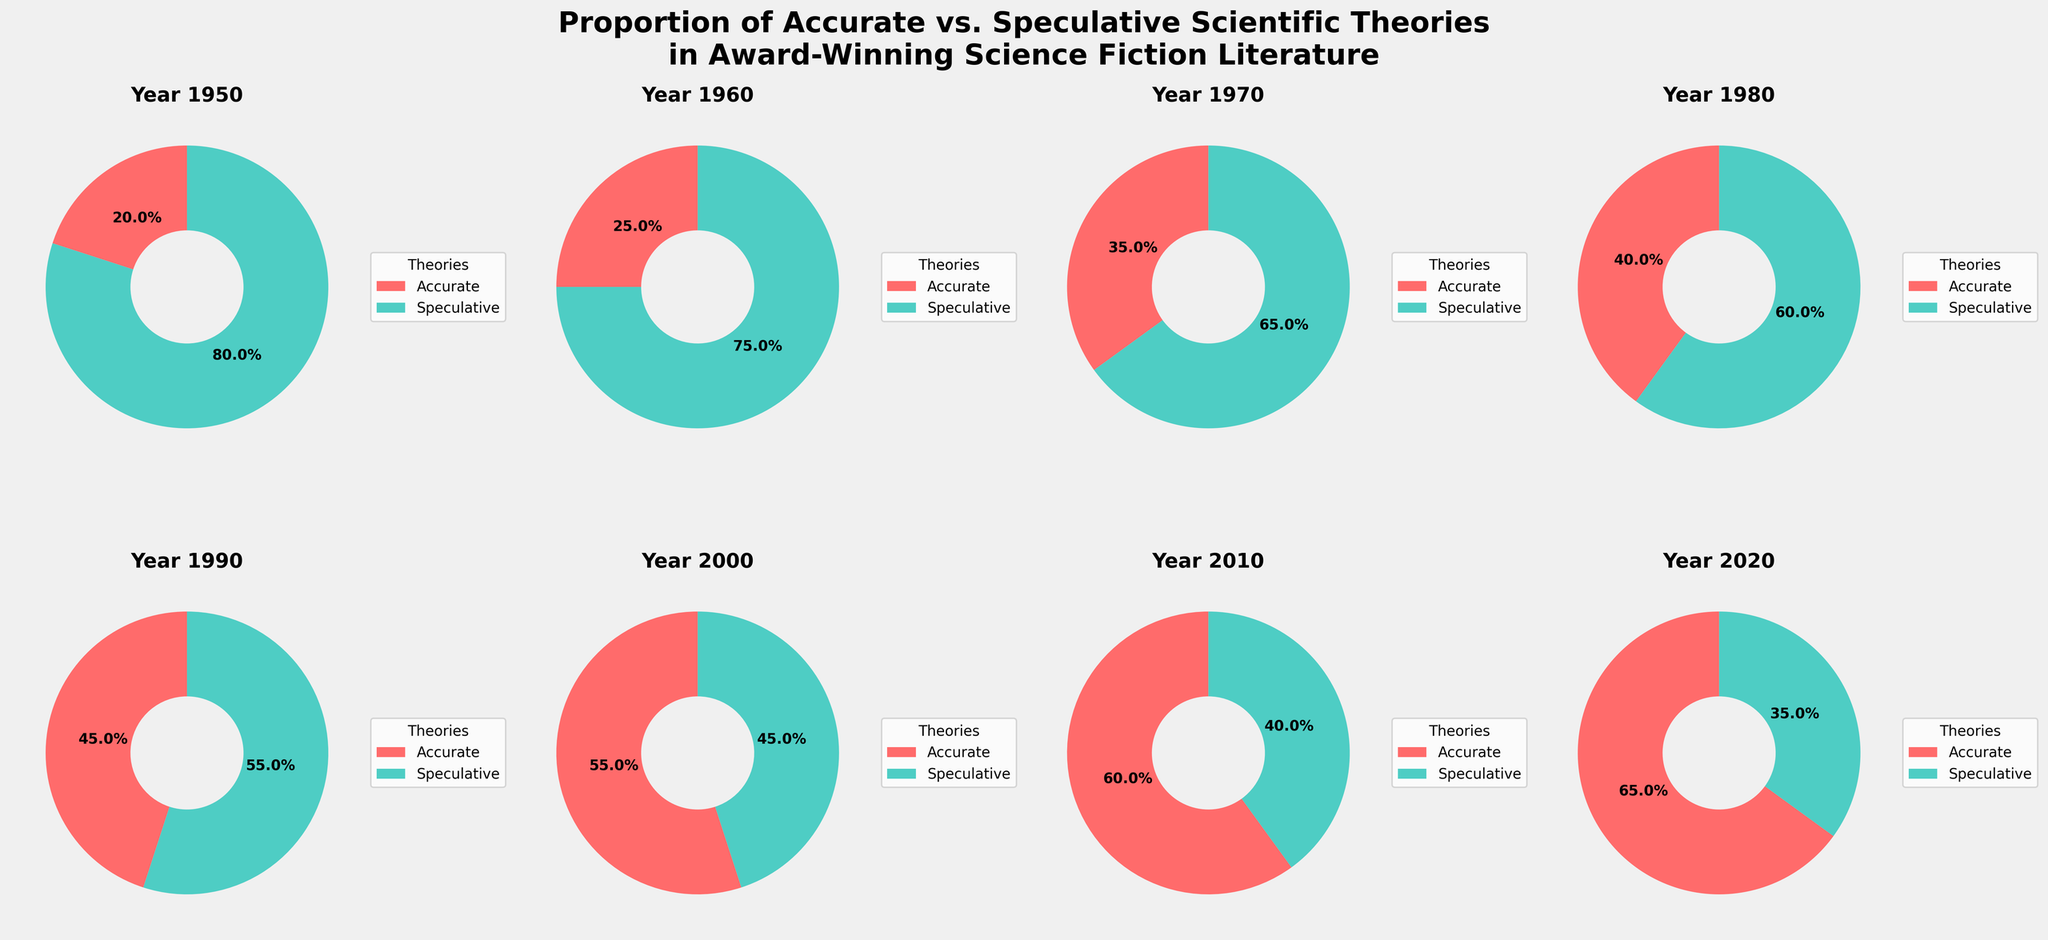Which year had the highest proportion of accurate scientific theories? By looking at the pie chart slices and their percentages, the year with the highest proportion of accurate scientific theories can be found out. From the figure, it's clear that 2020 has the largest slice for accurate theories.
Answer: 2020 What's the difference in the percentage of accurate theories between 1970 and 2000? From the pie charts, the percentage of accurate theories in 1970 is 35%. In 2000, it's 55%. To find the difference, subtract the 1970 value from the 2000 value: 55% - 35% = 20%.
Answer: 20% In terms of speculative theories, which is greater, the percentage in 1980 or 2010? Comparing the respective slices for speculative theories, 1980 has 60% and 2010 has 40%. As 60% is greater than 40%, the result is that 1980 has a greater percentage.
Answer: 1980 What is the average percentage of accurate theories for the years 1950, 1960, and 1970? The percentages for accurate theories in these years are 20%, 25%, and 35%, respectively. Summing them gives 20% + 25% + 35% = 80%. Dividing by 3 for the average: 80% / 3 = approximately 26.67%.
Answer: 26.67% How has the proportion of accurate theories changed from 1950 to 2020? The pie charts show the percentage of accurate theories in 1950 as 20% and in 2020 as 65%. Subtracting the 1950 value from the 2020 value: 65% - 20% = 45%. Thus, the proportion of accurate theories has increased by 45%.
Answer: Increased by 45% If you combine the percentages of accurate theories from the 1950s and 1960s, how does it compare to the percentage from 2020? Adding accurate theories percentages of 1950 (20%) and 1960 (25%) gives 20% + 25% = 45%. Comparing this to the 2020 percentage (65%), 65% is greater.
Answer: 65% is greater Which year saw an equal distribution of accurate and speculative theories? By examining the pie charts, the year when the proportions of accurate and speculative theories are closest to being equal is 1990, where accurate is 45% and speculative is 55%.
Answer: 1990 Compare the trends observed in accurate theories from 1950 to 2020. What can be inferred? Analyzing the sequential increase in the proportion of accurate theories from 1950 (20%) to 2020 (65%), there is a clear upward trend. It indicates that over time, award-winning science fiction literature has increasingly incorporated accurate scientific theories.
Answer: Increasing trend Between 2000 and 2020, by what percentage did the speculative theories' proportion decrease? In 2000, speculative theories were 45%, and in 2020, they were 35%. To find the percentage decrease: 45% - 35% = 10%. Therefore, the proportion of speculative theories decreased by 10%.
Answer: 10% Considering 1980, what is the ratio of speculative to accurate theories? For 1980, the pie chart shows 60% speculative and 40% accurate theories. The ratio of speculative to accurate theories is hence 60%/40%, which simplifies to 3:2.
Answer: 3:2 